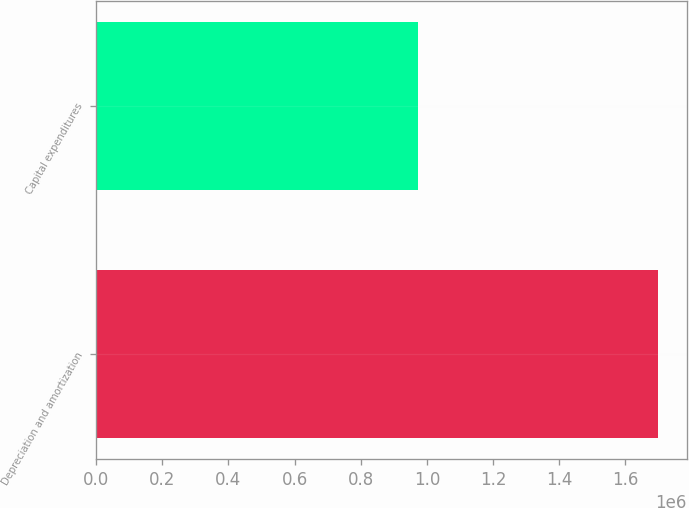<chart> <loc_0><loc_0><loc_500><loc_500><bar_chart><fcel>Depreciation and amortization<fcel>Capital expenditures<nl><fcel>1.70005e+06<fcel>973301<nl></chart> 